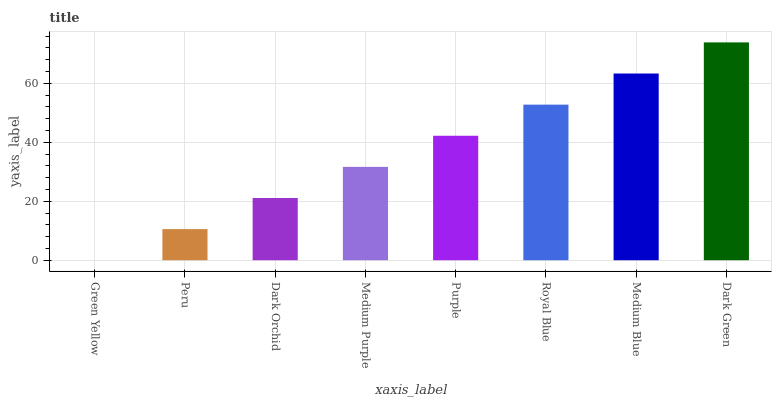Is Green Yellow the minimum?
Answer yes or no. Yes. Is Dark Green the maximum?
Answer yes or no. Yes. Is Peru the minimum?
Answer yes or no. No. Is Peru the maximum?
Answer yes or no. No. Is Peru greater than Green Yellow?
Answer yes or no. Yes. Is Green Yellow less than Peru?
Answer yes or no. Yes. Is Green Yellow greater than Peru?
Answer yes or no. No. Is Peru less than Green Yellow?
Answer yes or no. No. Is Purple the high median?
Answer yes or no. Yes. Is Medium Purple the low median?
Answer yes or no. Yes. Is Green Yellow the high median?
Answer yes or no. No. Is Dark Green the low median?
Answer yes or no. No. 